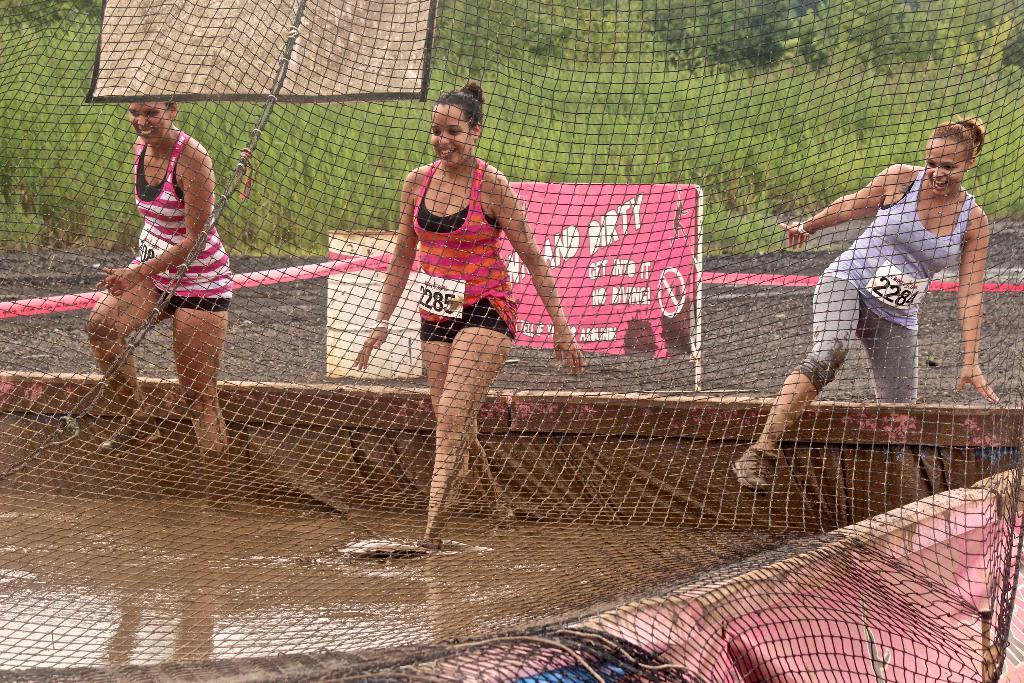<image>
Create a compact narrative representing the image presented. A woman wearing number 2285 is walking through a muddy puddle with other athletes. 